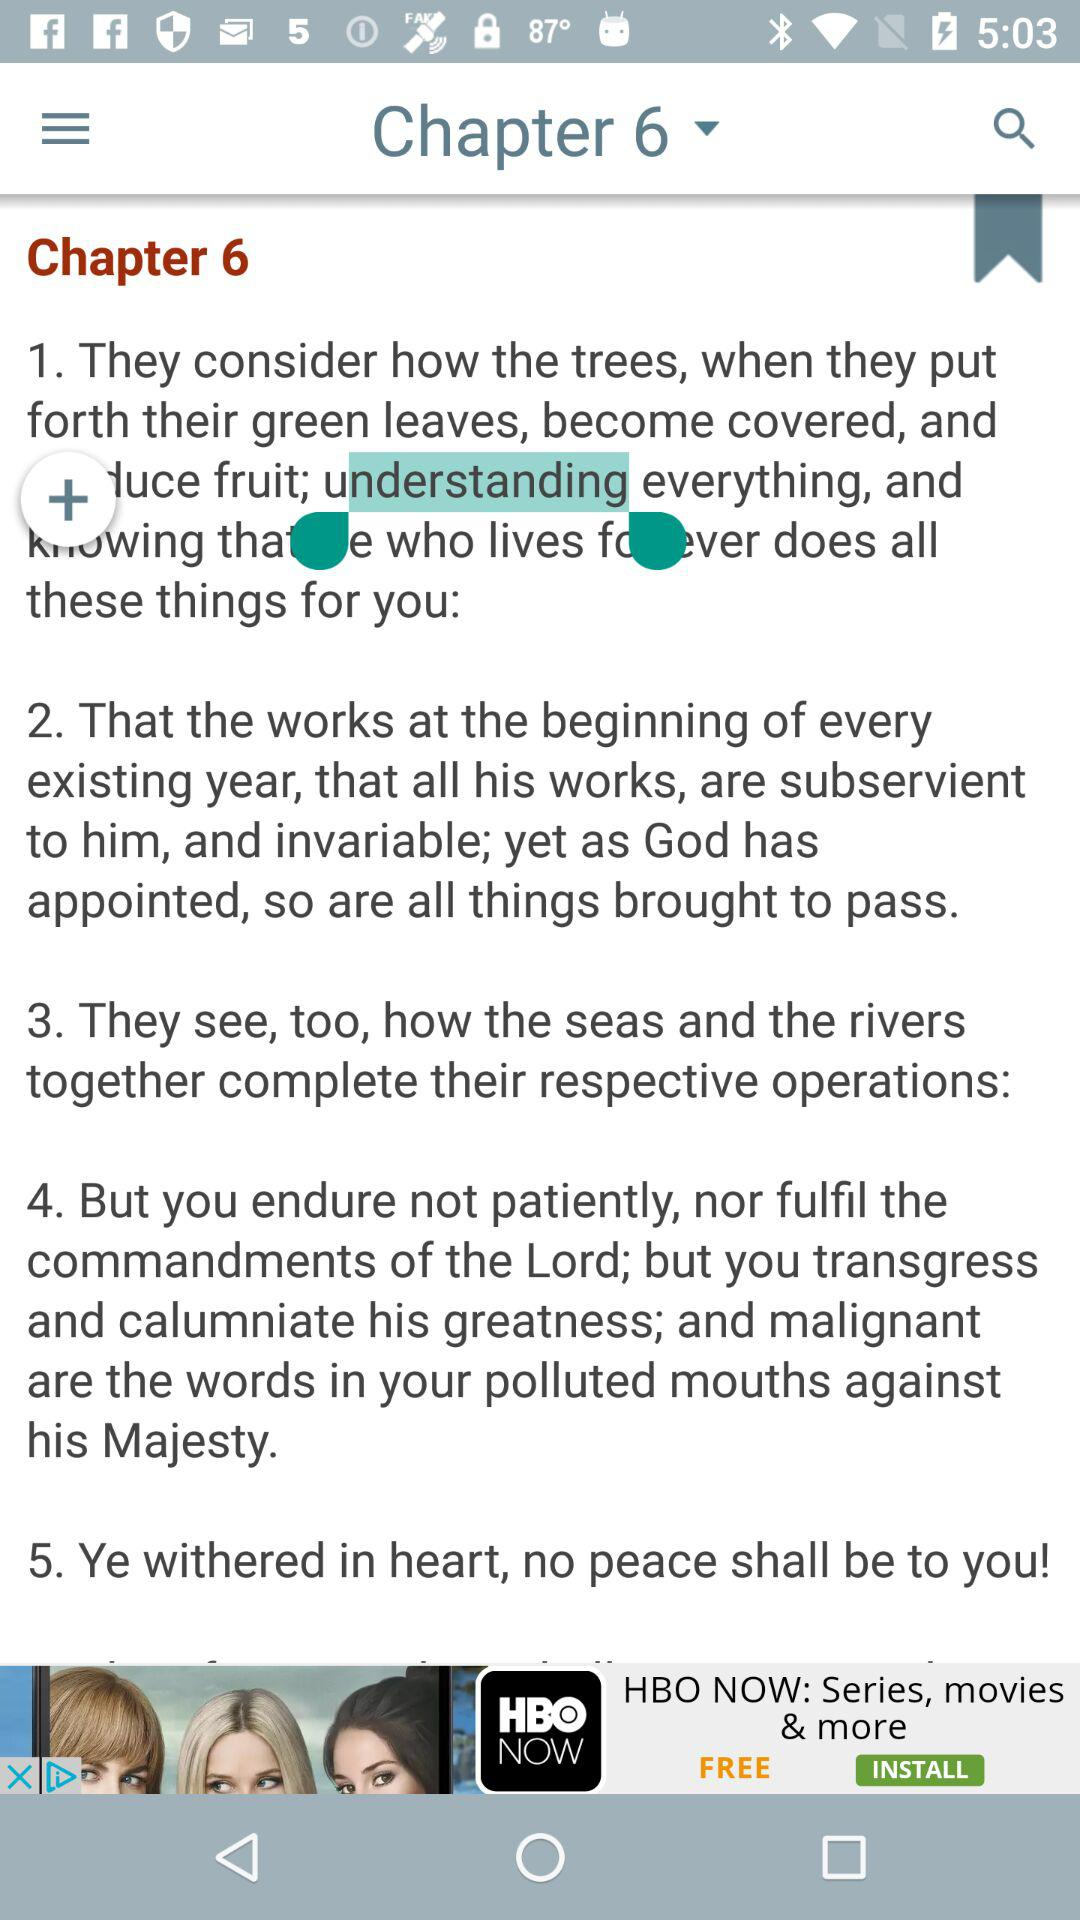How many sentences are in the text?
Answer the question using a single word or phrase. 5 